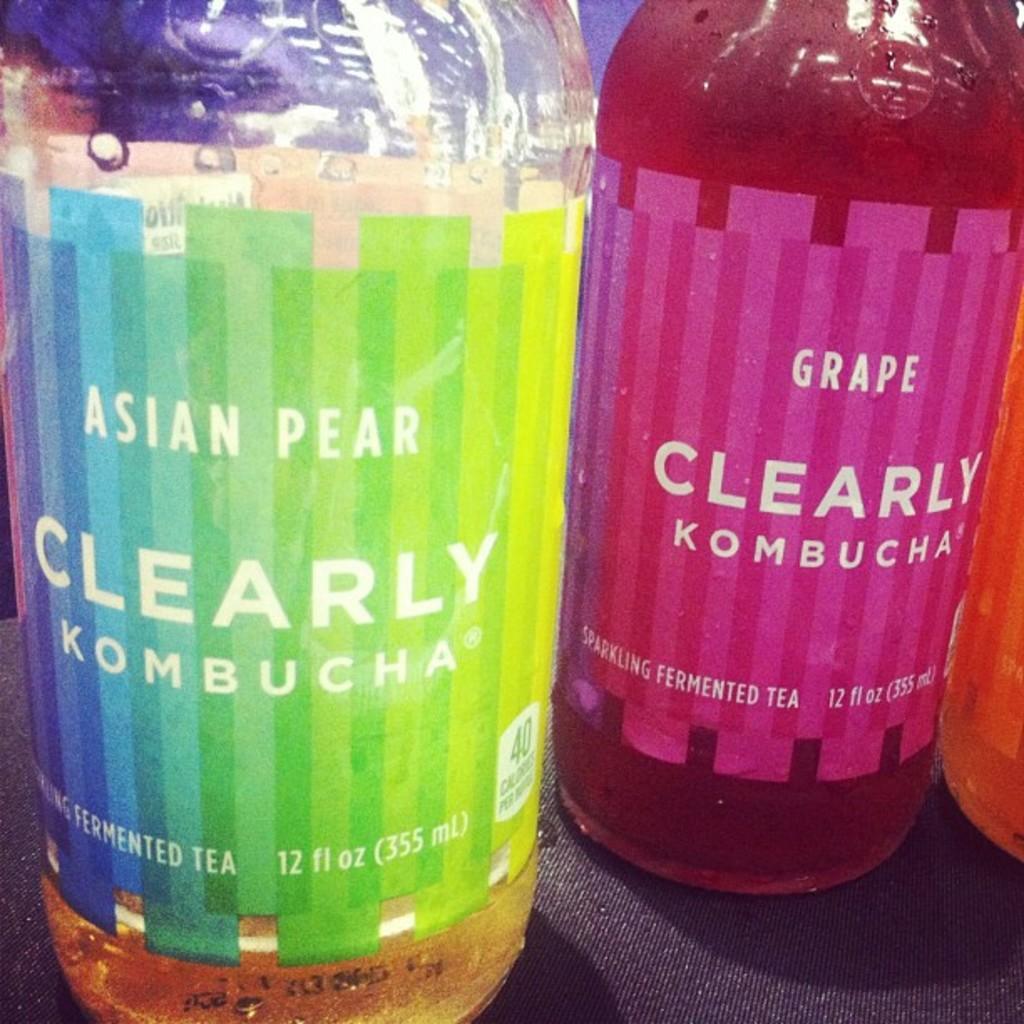Describe this image in one or two sentences. In the foreground of this image, there are three bottles on a black surface and there is wrapped around it. 